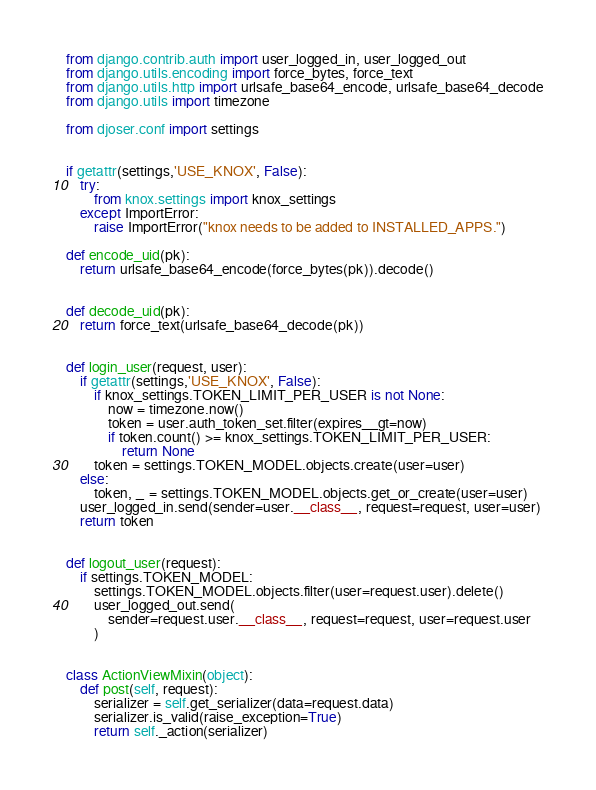<code> <loc_0><loc_0><loc_500><loc_500><_Python_>from django.contrib.auth import user_logged_in, user_logged_out
from django.utils.encoding import force_bytes, force_text
from django.utils.http import urlsafe_base64_encode, urlsafe_base64_decode
from django.utils import timezone

from djoser.conf import settings


if getattr(settings,'USE_KNOX', False):
    try:
        from knox.settings import knox_settings
    except ImportError:
        raise ImportError("knox needs to be added to INSTALLED_APPS.")

def encode_uid(pk):
    return urlsafe_base64_encode(force_bytes(pk)).decode()


def decode_uid(pk):
    return force_text(urlsafe_base64_decode(pk))


def login_user(request, user):
    if getattr(settings,'USE_KNOX', False):
        if knox_settings.TOKEN_LIMIT_PER_USER is not None:
            now = timezone.now()
            token = user.auth_token_set.filter(expires__gt=now)
            if token.count() >= knox_settings.TOKEN_LIMIT_PER_USER:
                return None
        token = settings.TOKEN_MODEL.objects.create(user=user)
    else:
        token, _ = settings.TOKEN_MODEL.objects.get_or_create(user=user)
    user_logged_in.send(sender=user.__class__, request=request, user=user)
    return token


def logout_user(request):
    if settings.TOKEN_MODEL:
        settings.TOKEN_MODEL.objects.filter(user=request.user).delete()
        user_logged_out.send(
            sender=request.user.__class__, request=request, user=request.user
        )


class ActionViewMixin(object):
    def post(self, request):
        serializer = self.get_serializer(data=request.data)
        serializer.is_valid(raise_exception=True)
        return self._action(serializer)
</code> 